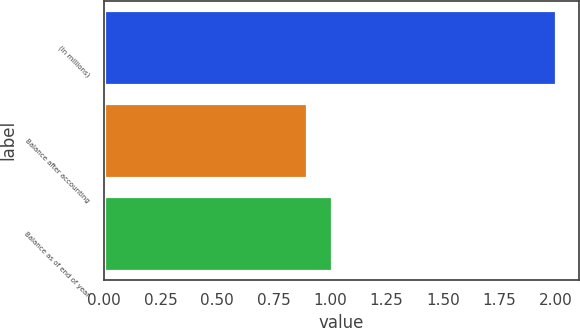Convert chart to OTSL. <chart><loc_0><loc_0><loc_500><loc_500><bar_chart><fcel>(In millions)<fcel>Balance after accounting<fcel>Balance as of end of year<nl><fcel>2<fcel>0.9<fcel>1.01<nl></chart> 